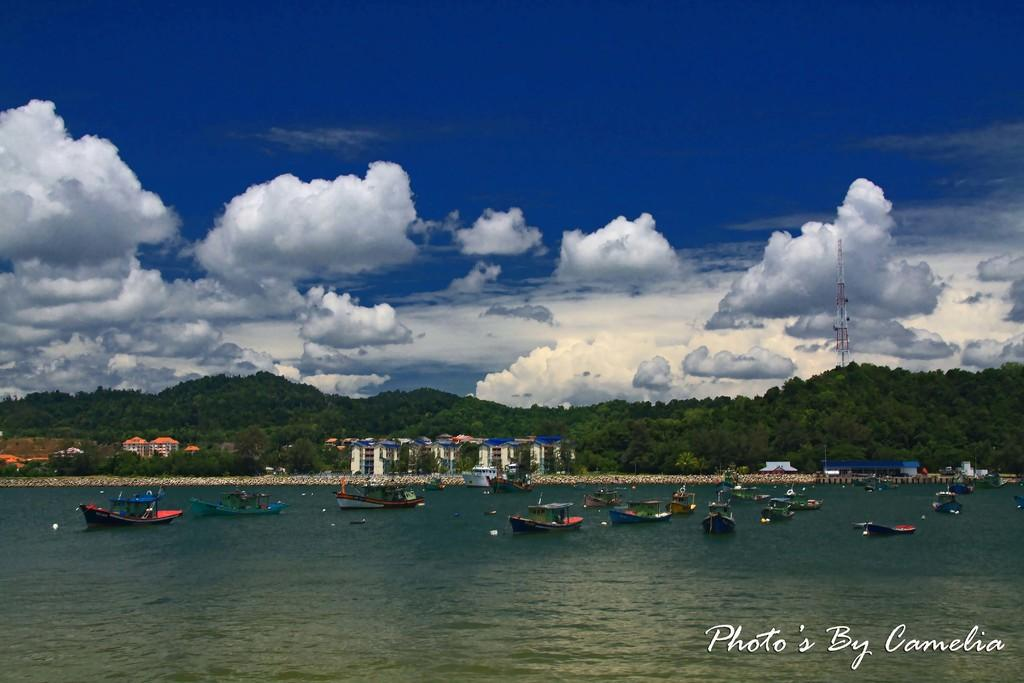What is on the water in the image? There are boats on the water in the image. What can be seen in the background of the image? There are buildings, trees, a tower, and the sky visible in the background of the image. Can you describe the watermark in the image? A: There is a watermark in the bottom right corner of the image. What type of pie is being served in the image? There is no pie present in the image; it features boats on the water and various background elements. Can you tell me how many turkeys are visible in the image? There are no turkeys visible in the image. 